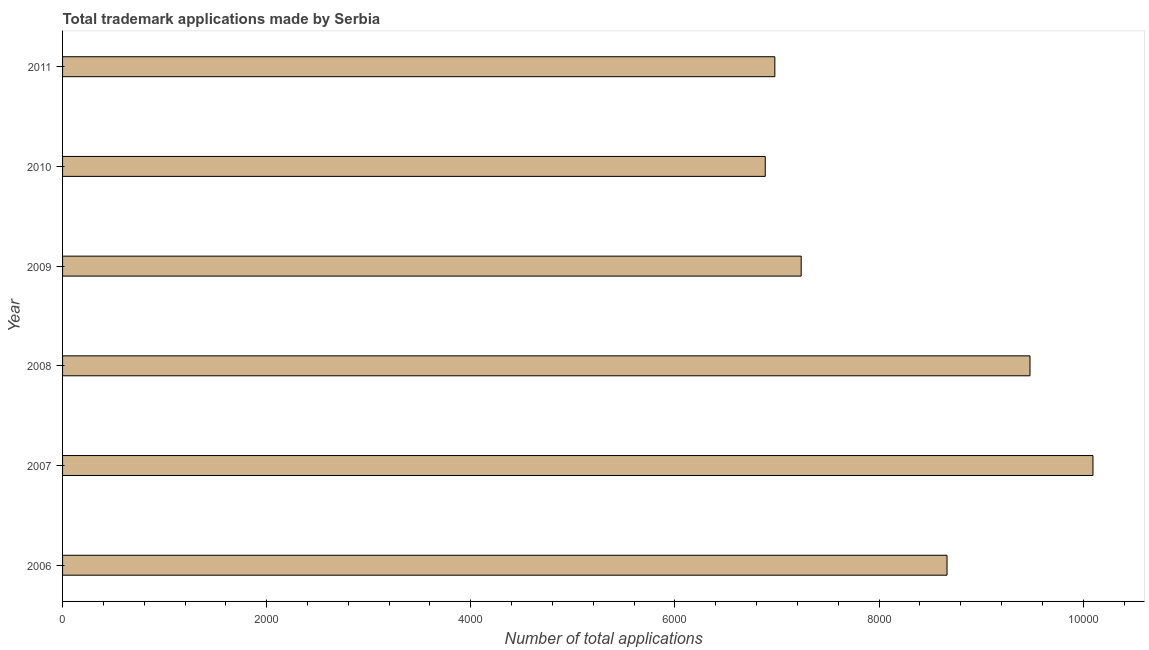Does the graph contain grids?
Your answer should be compact. No. What is the title of the graph?
Ensure brevity in your answer.  Total trademark applications made by Serbia. What is the label or title of the X-axis?
Give a very brief answer. Number of total applications. What is the label or title of the Y-axis?
Provide a succinct answer. Year. What is the number of trademark applications in 2011?
Offer a very short reply. 6979. Across all years, what is the maximum number of trademark applications?
Provide a short and direct response. 1.01e+04. Across all years, what is the minimum number of trademark applications?
Offer a very short reply. 6885. What is the sum of the number of trademark applications?
Provide a succinct answer. 4.93e+04. What is the difference between the number of trademark applications in 2006 and 2007?
Offer a very short reply. -1430. What is the average number of trademark applications per year?
Your response must be concise. 8223. What is the median number of trademark applications?
Provide a succinct answer. 7951.5. In how many years, is the number of trademark applications greater than 7600 ?
Give a very brief answer. 3. Do a majority of the years between 2011 and 2006 (inclusive) have number of trademark applications greater than 1600 ?
Offer a very short reply. Yes. What is the ratio of the number of trademark applications in 2006 to that in 2010?
Your answer should be very brief. 1.26. Is the number of trademark applications in 2008 less than that in 2009?
Your response must be concise. No. Is the difference between the number of trademark applications in 2006 and 2007 greater than the difference between any two years?
Provide a short and direct response. No. What is the difference between the highest and the second highest number of trademark applications?
Provide a short and direct response. 617. Is the sum of the number of trademark applications in 2010 and 2011 greater than the maximum number of trademark applications across all years?
Offer a very short reply. Yes. What is the difference between the highest and the lowest number of trademark applications?
Give a very brief answer. 3211. In how many years, is the number of trademark applications greater than the average number of trademark applications taken over all years?
Offer a terse response. 3. What is the Number of total applications of 2006?
Give a very brief answer. 8666. What is the Number of total applications in 2007?
Offer a terse response. 1.01e+04. What is the Number of total applications of 2008?
Your answer should be compact. 9479. What is the Number of total applications of 2009?
Make the answer very short. 7237. What is the Number of total applications in 2010?
Your answer should be compact. 6885. What is the Number of total applications of 2011?
Give a very brief answer. 6979. What is the difference between the Number of total applications in 2006 and 2007?
Provide a succinct answer. -1430. What is the difference between the Number of total applications in 2006 and 2008?
Your response must be concise. -813. What is the difference between the Number of total applications in 2006 and 2009?
Provide a short and direct response. 1429. What is the difference between the Number of total applications in 2006 and 2010?
Your answer should be compact. 1781. What is the difference between the Number of total applications in 2006 and 2011?
Ensure brevity in your answer.  1687. What is the difference between the Number of total applications in 2007 and 2008?
Give a very brief answer. 617. What is the difference between the Number of total applications in 2007 and 2009?
Provide a short and direct response. 2859. What is the difference between the Number of total applications in 2007 and 2010?
Ensure brevity in your answer.  3211. What is the difference between the Number of total applications in 2007 and 2011?
Offer a terse response. 3117. What is the difference between the Number of total applications in 2008 and 2009?
Your answer should be very brief. 2242. What is the difference between the Number of total applications in 2008 and 2010?
Keep it short and to the point. 2594. What is the difference between the Number of total applications in 2008 and 2011?
Make the answer very short. 2500. What is the difference between the Number of total applications in 2009 and 2010?
Ensure brevity in your answer.  352. What is the difference between the Number of total applications in 2009 and 2011?
Make the answer very short. 258. What is the difference between the Number of total applications in 2010 and 2011?
Give a very brief answer. -94. What is the ratio of the Number of total applications in 2006 to that in 2007?
Your answer should be compact. 0.86. What is the ratio of the Number of total applications in 2006 to that in 2008?
Give a very brief answer. 0.91. What is the ratio of the Number of total applications in 2006 to that in 2009?
Give a very brief answer. 1.2. What is the ratio of the Number of total applications in 2006 to that in 2010?
Your response must be concise. 1.26. What is the ratio of the Number of total applications in 2006 to that in 2011?
Offer a very short reply. 1.24. What is the ratio of the Number of total applications in 2007 to that in 2008?
Offer a very short reply. 1.06. What is the ratio of the Number of total applications in 2007 to that in 2009?
Keep it short and to the point. 1.4. What is the ratio of the Number of total applications in 2007 to that in 2010?
Provide a succinct answer. 1.47. What is the ratio of the Number of total applications in 2007 to that in 2011?
Ensure brevity in your answer.  1.45. What is the ratio of the Number of total applications in 2008 to that in 2009?
Keep it short and to the point. 1.31. What is the ratio of the Number of total applications in 2008 to that in 2010?
Offer a very short reply. 1.38. What is the ratio of the Number of total applications in 2008 to that in 2011?
Offer a very short reply. 1.36. What is the ratio of the Number of total applications in 2009 to that in 2010?
Provide a succinct answer. 1.05. 